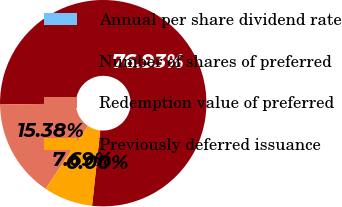Convert chart to OTSL. <chart><loc_0><loc_0><loc_500><loc_500><pie_chart><fcel>Annual per share dividend rate<fcel>Number of shares of preferred<fcel>Redemption value of preferred<fcel>Previously deferred issuance<nl><fcel>0.0%<fcel>76.92%<fcel>15.38%<fcel>7.69%<nl></chart> 